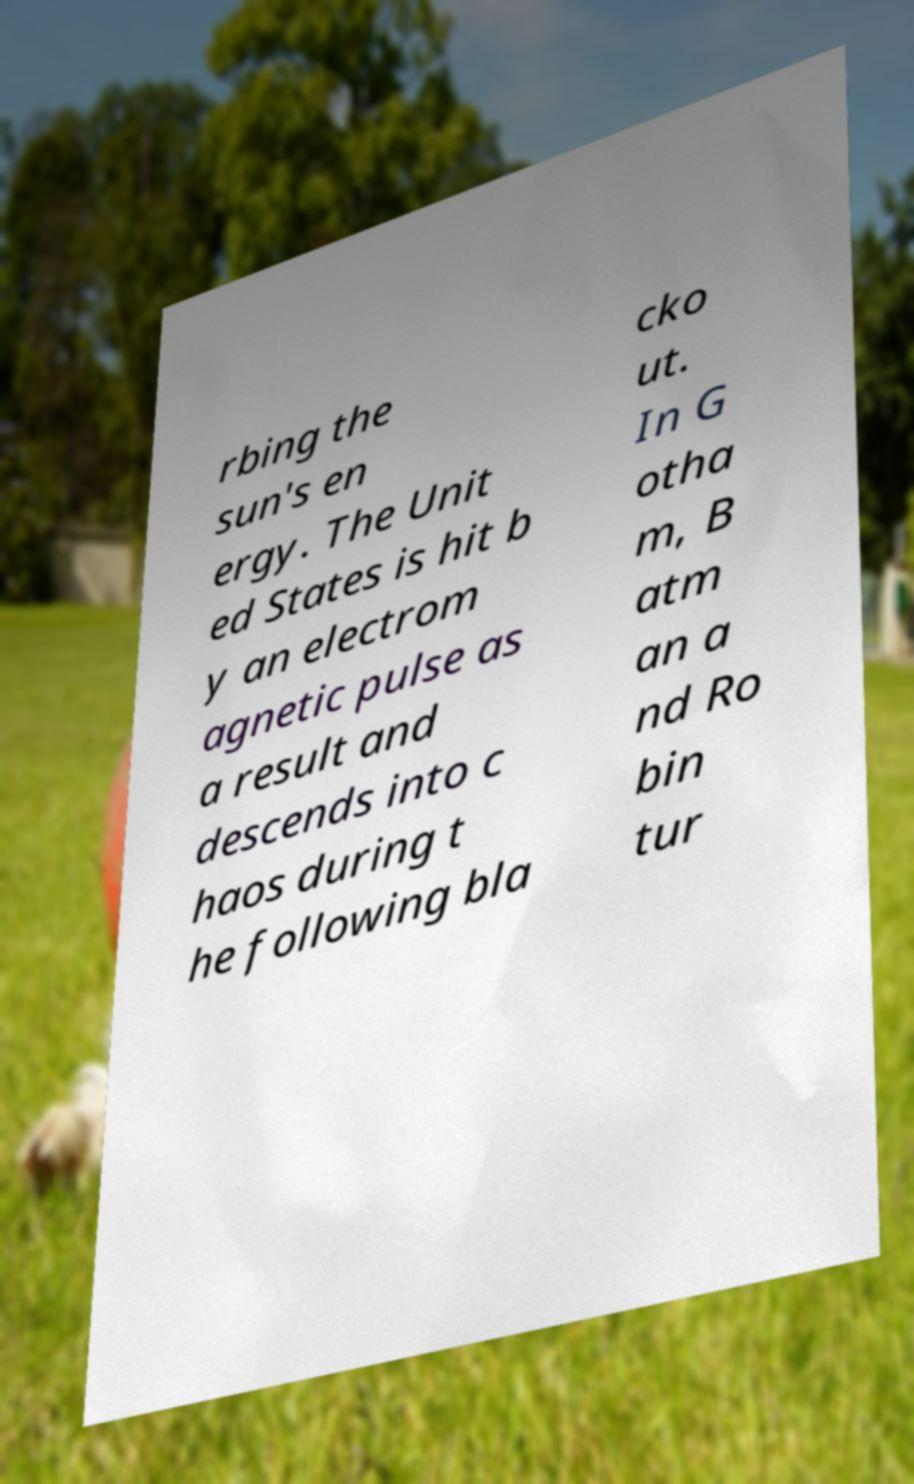Could you extract and type out the text from this image? rbing the sun's en ergy. The Unit ed States is hit b y an electrom agnetic pulse as a result and descends into c haos during t he following bla cko ut. In G otha m, B atm an a nd Ro bin tur 